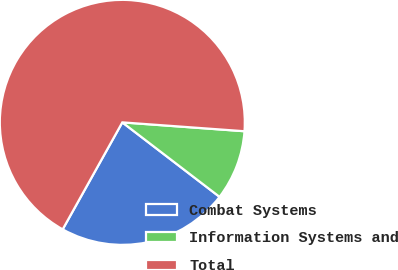<chart> <loc_0><loc_0><loc_500><loc_500><pie_chart><fcel>Combat Systems<fcel>Information Systems and<fcel>Total<nl><fcel>22.69%<fcel>9.25%<fcel>68.06%<nl></chart> 